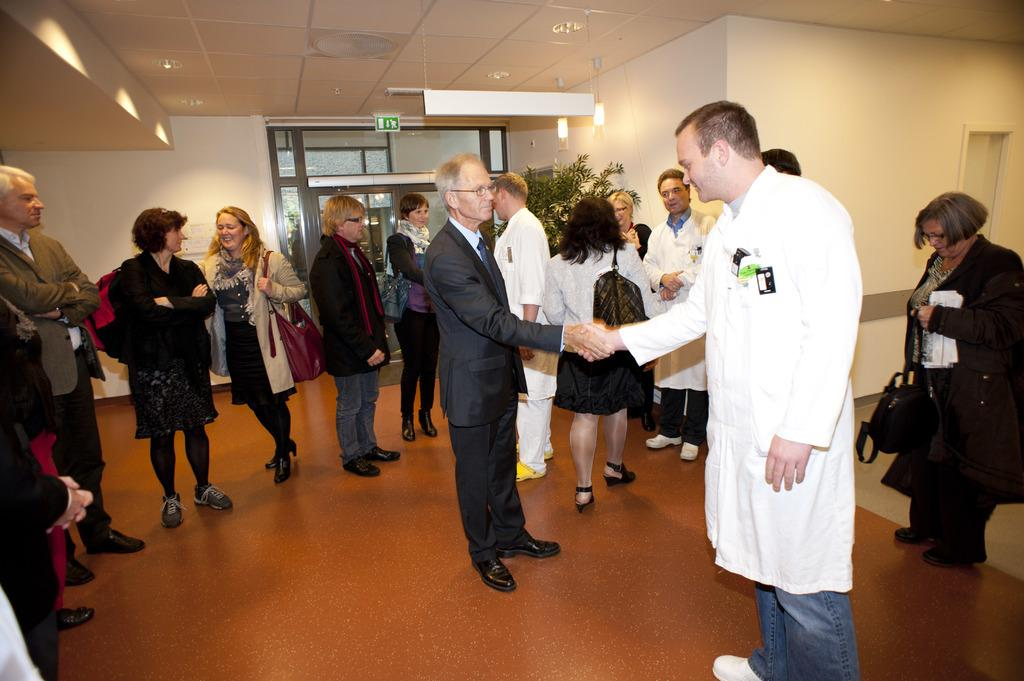How many people are in the group in the image? There is a group of people in the image, but the exact number cannot be determined from the provided facts. What are some people in the group carrying? Some people in the group are carrying bags. What can be seen in the background of the image? There are lights, a sign board, and a tree visible in the background of the image. How many dimes are scattered on the ground in the image? There is no mention of dimes in the provided facts, so we cannot determine if any are present in the image. 